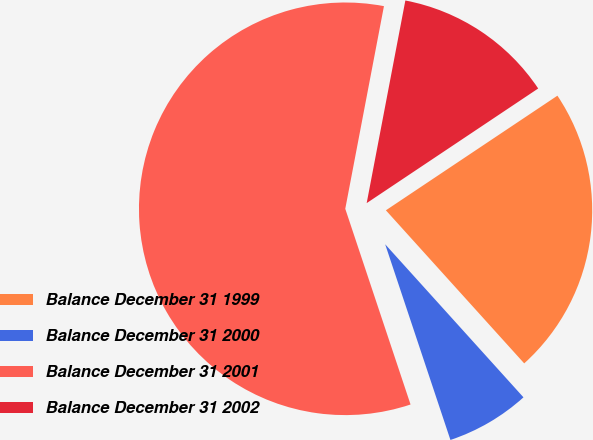Convert chart to OTSL. <chart><loc_0><loc_0><loc_500><loc_500><pie_chart><fcel>Balance December 31 1999<fcel>Balance December 31 2000<fcel>Balance December 31 2001<fcel>Balance December 31 2002<nl><fcel>22.68%<fcel>6.57%<fcel>58.12%<fcel>12.62%<nl></chart> 